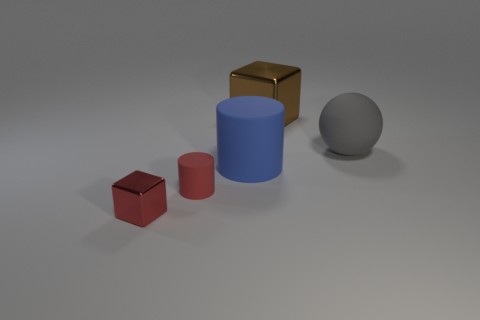Add 5 yellow things. How many objects exist? 10 Subtract 1 cubes. How many cubes are left? 1 Subtract all brown cylinders. Subtract all blue cubes. How many cylinders are left? 2 Subtract all green cylinders. How many brown cubes are left? 1 Subtract all small blue shiny things. Subtract all red shiny things. How many objects are left? 4 Add 1 red objects. How many red objects are left? 3 Add 5 tiny cylinders. How many tiny cylinders exist? 6 Subtract 0 gray cylinders. How many objects are left? 5 Subtract all spheres. How many objects are left? 4 